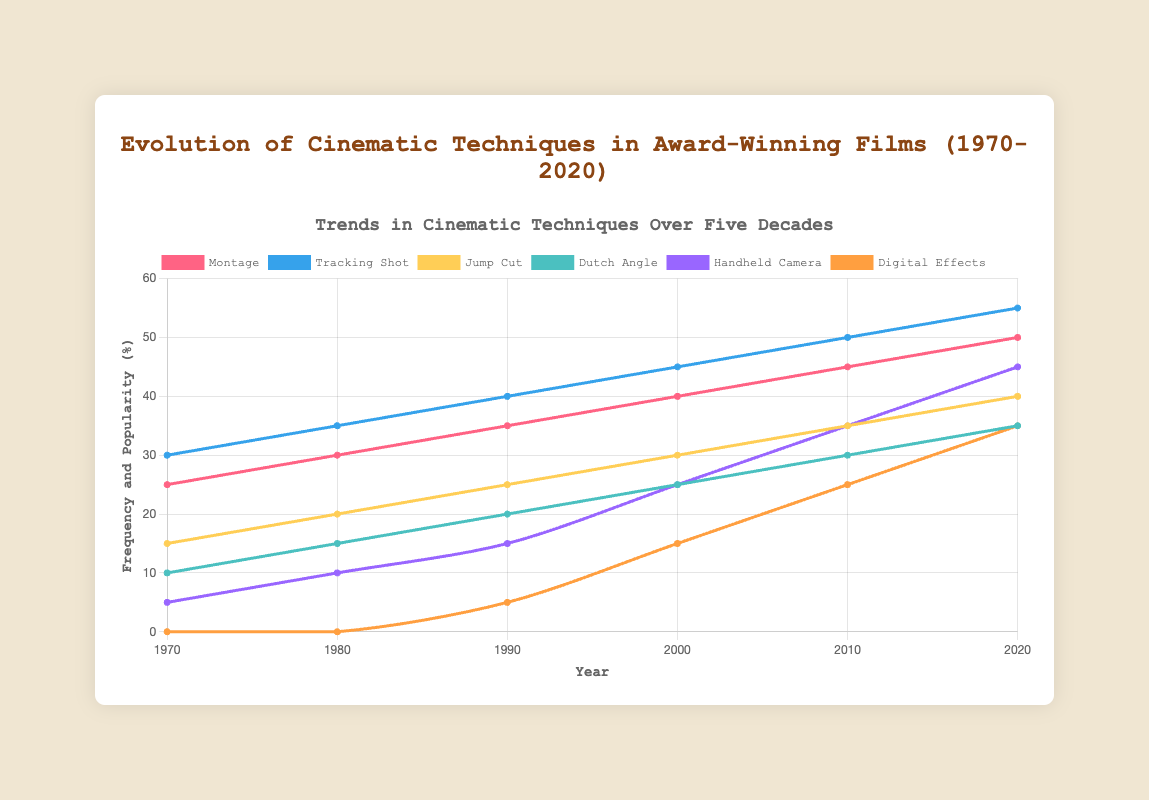What cinematic technique had the highest frequency in 2020? By looking at the 2020 data on the plot, the tracking shot has the highest frequency at 55%.
Answer: Tracking shot Which year showed the highest frequency for handheld camera techniques, and what was the value? Handheld camera techniques peaked in 2020 with a frequency of 45%, as indicated by the data for 2020.
Answer: 2020, 45% How did the popularity of montage change from 1970 to 2020? In 1970, the montage had a frequency of 25%. By 2020, it had increased to 50%. Thus, it doubled over this period.
Answer: It doubled from 25% to 50% Compare the frequency of digital effects and jump cuts in 2000. Which one was higher and by how much? In 2000, digital effects had a frequency of 15%, while jump cuts had 30%. Jump cuts were 15% higher than digital effects.
Answer: Jump cuts, 15% What is the average frequency of Dutch angles from 1970 to 2020? The frequencies for Dutch angles from 1970 to 2020 are 10%, 15%, 20%, 25%, 30%, and 35%. The sum is 135% over 6 periods, so the average is 135 / 6 = 22.5%.
Answer: 22.5% Which cinematic technique had the lowest initial frequency in 1970, and what was its value? Handheld camera techniques had the lowest initial frequency in 1970, with a value of 5%.
Answer: Handheld camera, 5% By how much did the frequency of handheld camera techniques increase from 1990 to 2000? In 1990, the frequency was 15%, and by 2000 it was 25%, marking an increase of 10%.
Answer: 10% Calculate the combined frequency of montage and tracking shot techniques in 2010. In 2010, the frequencies for montage and tracking shot techniques were 45% and 50%, respectively. Thus, the combined frequency is 45 + 50 = 95%.
Answer: 95% Visually, which technique shows the steepest increase in frequency from 1990 to 2000, and what is the difference in frequency values? Handheld cameras show the steepest increase, rising from 15% in 1990 to 25% in 2000, a difference of 10%.
Answer: Handheld camera, 10% Which technique saw its first introduction within the examined period, and in which year did this occur? Digital effects were introduced in the examined period, first appearing in 1990 with a frequency of 5%.
Answer: Digital effects, 1990 